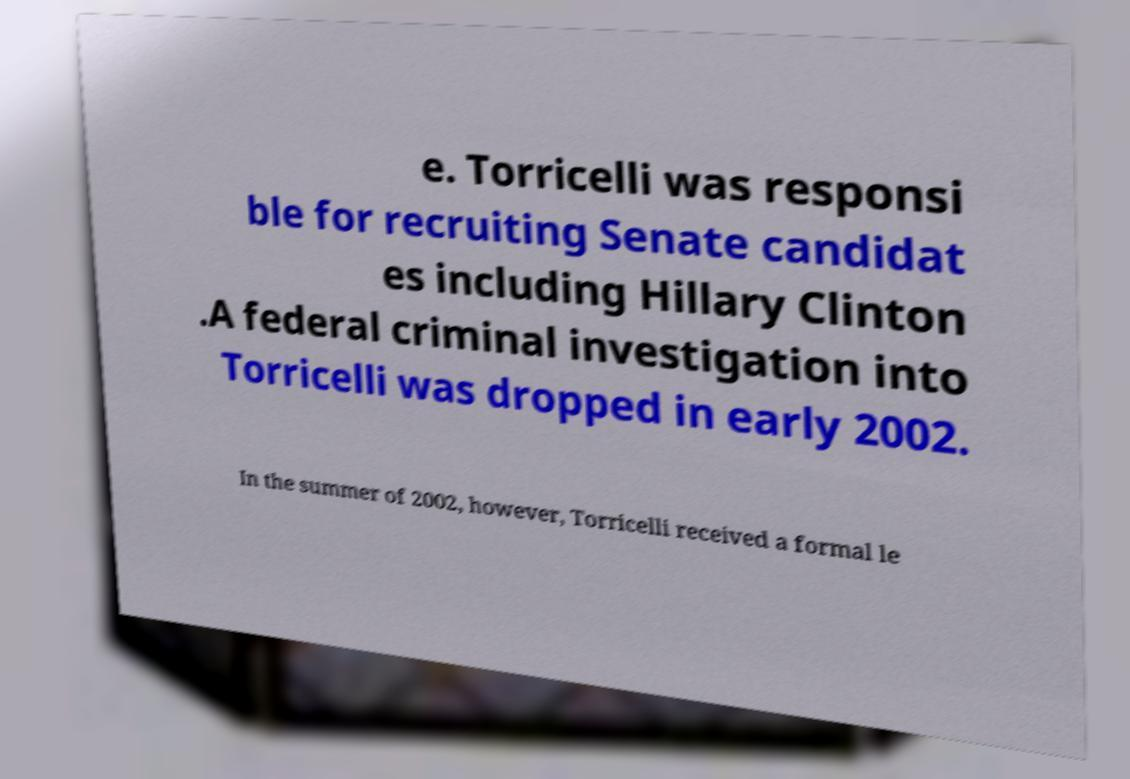There's text embedded in this image that I need extracted. Can you transcribe it verbatim? e. Torricelli was responsi ble for recruiting Senate candidat es including Hillary Clinton .A federal criminal investigation into Torricelli was dropped in early 2002. In the summer of 2002, however, Torricelli received a formal le 